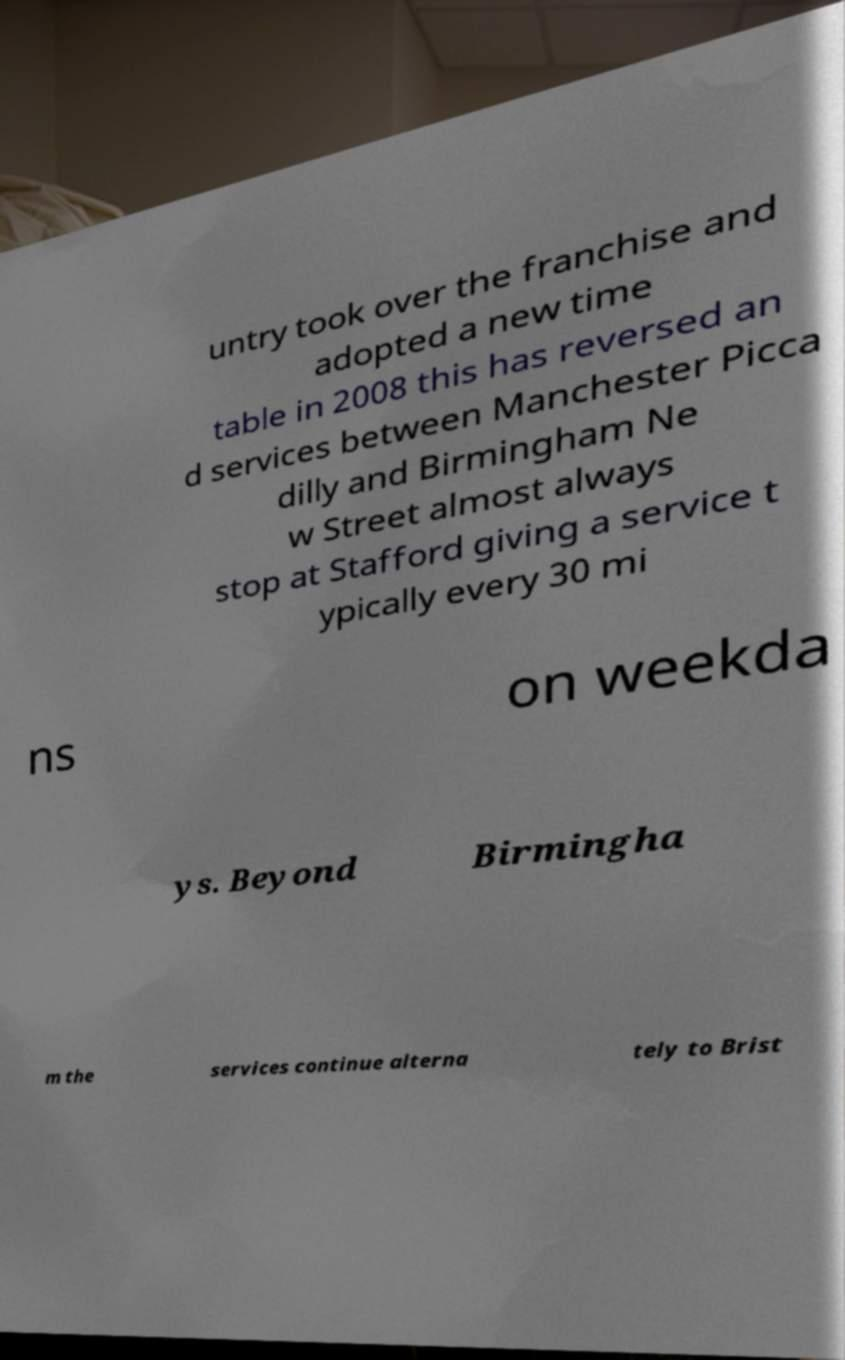I need the written content from this picture converted into text. Can you do that? untry took over the franchise and adopted a new time table in 2008 this has reversed an d services between Manchester Picca dilly and Birmingham Ne w Street almost always stop at Stafford giving a service t ypically every 30 mi ns on weekda ys. Beyond Birmingha m the services continue alterna tely to Brist 